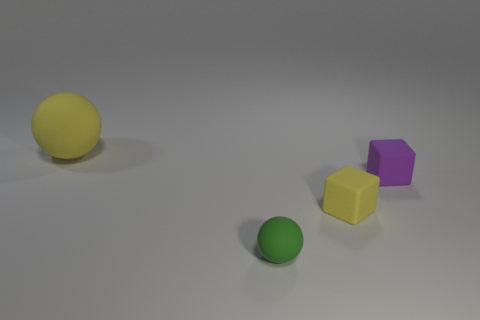Subtract 1 balls. How many balls are left? 1 Add 1 yellow objects. How many objects exist? 5 Subtract all small yellow matte blocks. Subtract all tiny purple cubes. How many objects are left? 2 Add 3 green matte objects. How many green matte objects are left? 4 Add 2 blue blocks. How many blue blocks exist? 2 Subtract 0 red balls. How many objects are left? 4 Subtract all yellow balls. Subtract all cyan cubes. How many balls are left? 1 Subtract all red blocks. How many yellow spheres are left? 1 